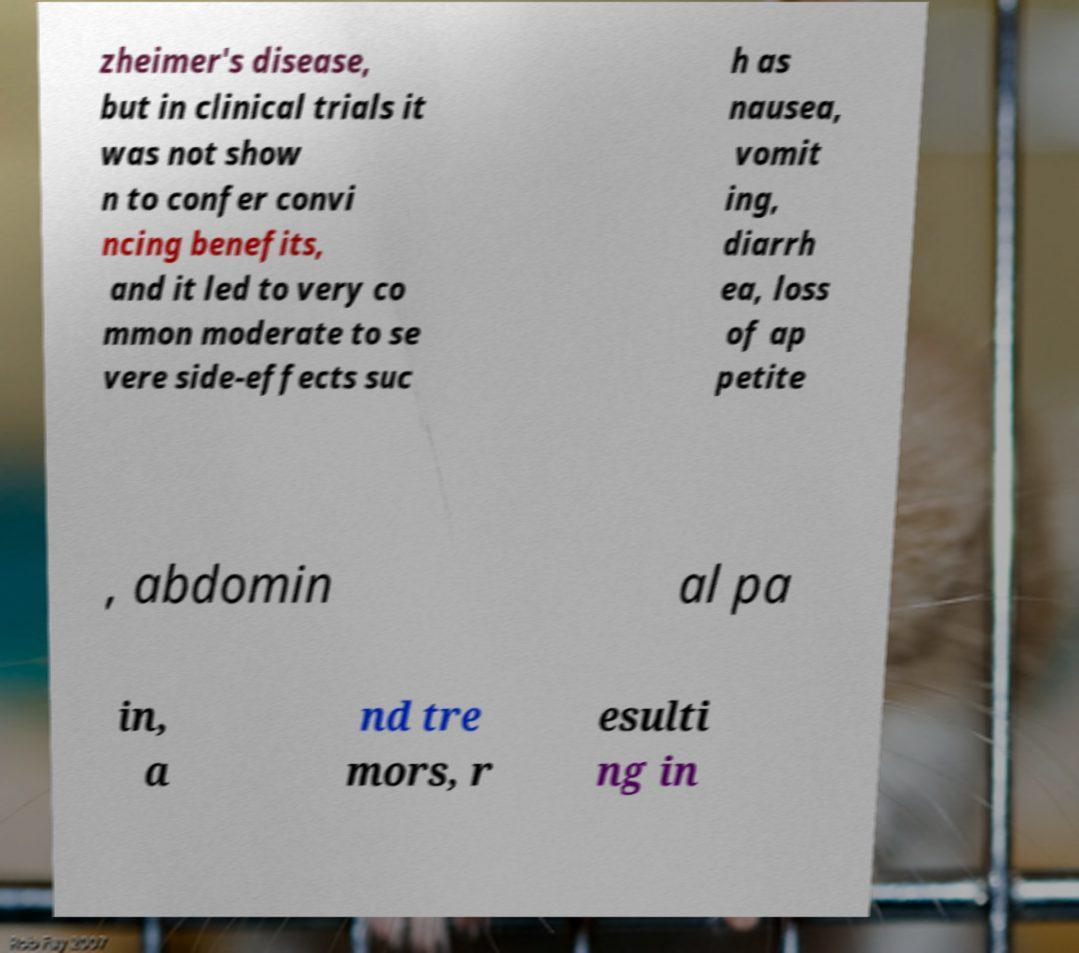Could you assist in decoding the text presented in this image and type it out clearly? zheimer's disease, but in clinical trials it was not show n to confer convi ncing benefits, and it led to very co mmon moderate to se vere side-effects suc h as nausea, vomit ing, diarrh ea, loss of ap petite , abdomin al pa in, a nd tre mors, r esulti ng in 